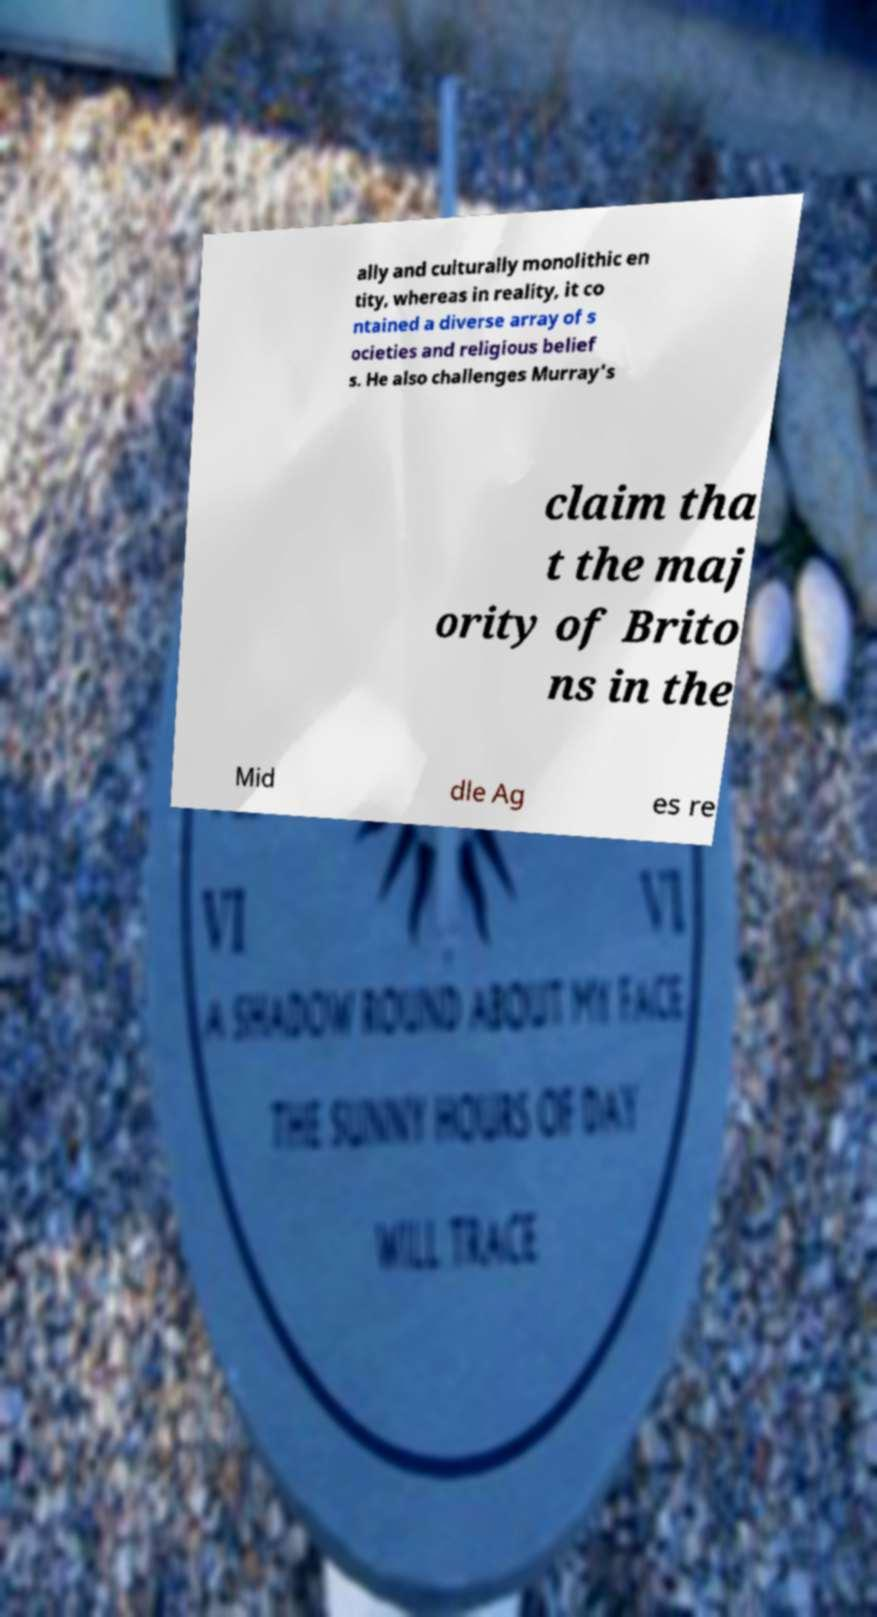For documentation purposes, I need the text within this image transcribed. Could you provide that? ally and culturally monolithic en tity, whereas in reality, it co ntained a diverse array of s ocieties and religious belief s. He also challenges Murray's claim tha t the maj ority of Brito ns in the Mid dle Ag es re 